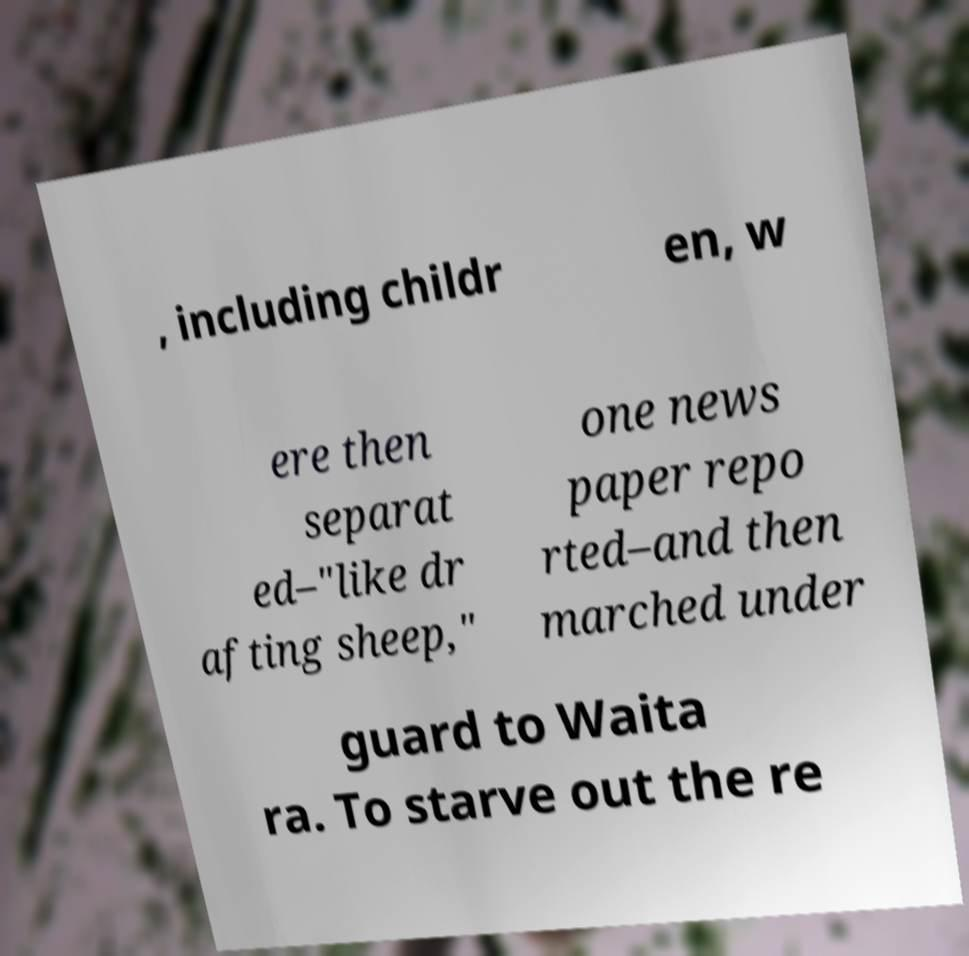Could you extract and type out the text from this image? , including childr en, w ere then separat ed–"like dr afting sheep," one news paper repo rted–and then marched under guard to Waita ra. To starve out the re 